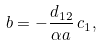Convert formula to latex. <formula><loc_0><loc_0><loc_500><loc_500>b = - \frac { d _ { 1 2 } } { \alpha a } \, c _ { 1 } ,</formula> 